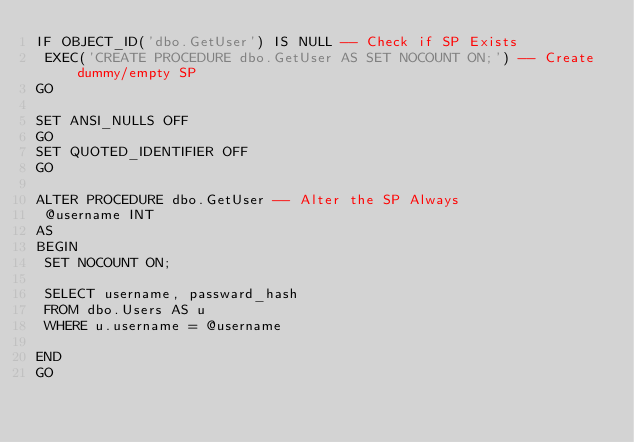<code> <loc_0><loc_0><loc_500><loc_500><_SQL_>IF OBJECT_ID('dbo.GetUser') IS NULL -- Check if SP Exists
 EXEC('CREATE PROCEDURE dbo.GetUser AS SET NOCOUNT ON;') -- Create dummy/empty SP
GO

SET ANSI_NULLS OFF
GO
SET QUOTED_IDENTIFIER OFF
GO

ALTER PROCEDURE dbo.GetUser -- Alter the SP Always
 @username INT
AS
BEGIN
 SET NOCOUNT ON;
  
 SELECT username, passward_hash
 FROM dbo.Users AS u
 WHERE u.username = @username
 
END
GO</code> 